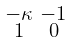Convert formula to latex. <formula><loc_0><loc_0><loc_500><loc_500>\begin{smallmatrix} - \kappa & - 1 \\ 1 & 0 \end{smallmatrix}</formula> 